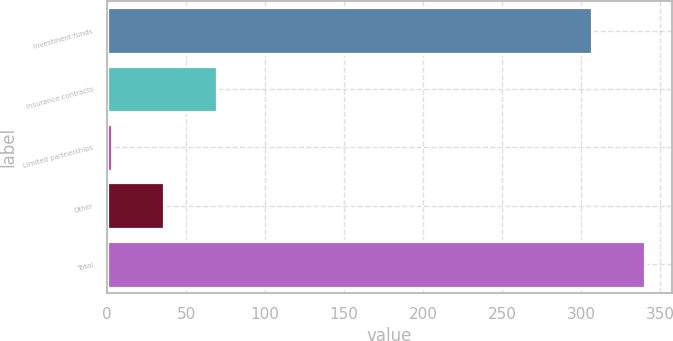Convert chart. <chart><loc_0><loc_0><loc_500><loc_500><bar_chart><fcel>Investment funds<fcel>Insurance contracts<fcel>Limited partnerships<fcel>Other<fcel>Total<nl><fcel>307.1<fcel>69.62<fcel>2.96<fcel>36.29<fcel>340.43<nl></chart> 